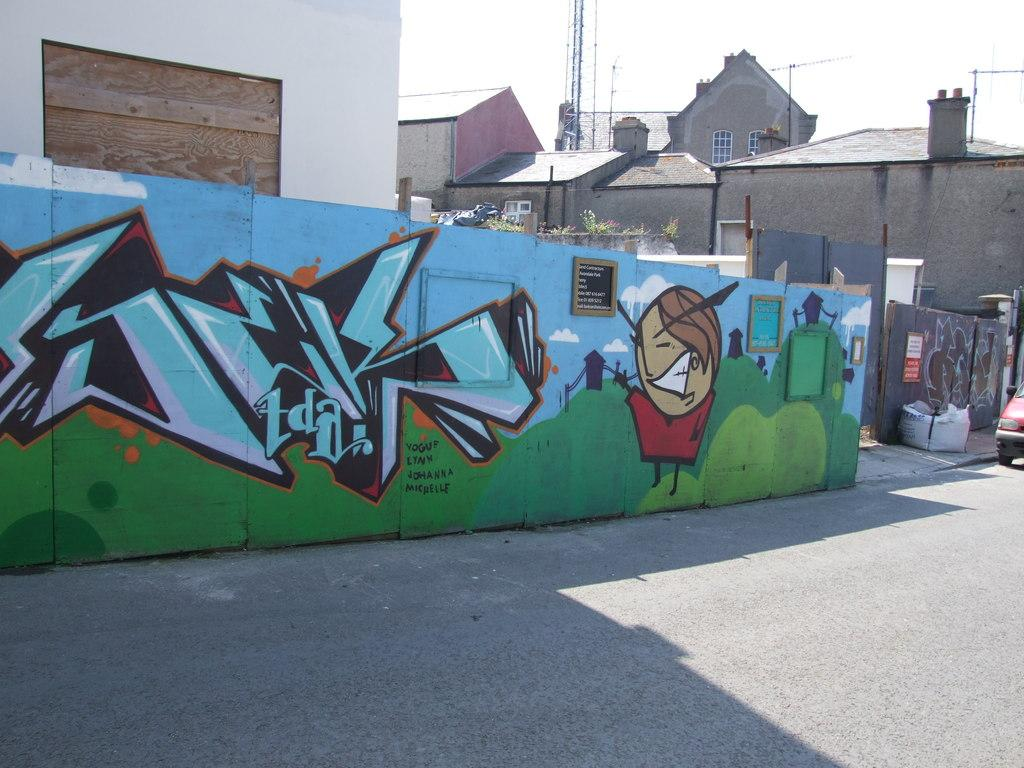What can be seen on the walls in the image? There are paintings on the walls in the image. What type of object is present in the image? There is a vehicle in the image. What structures are visible in the image? There are buildings in the image. What can be seen in the distance in the image? The sky is visible in the background of the image. Where are the bushes located in the image? There are no bushes present in the image. What type of ring is being worn by the person in the image? There is no person or ring present in the image. 